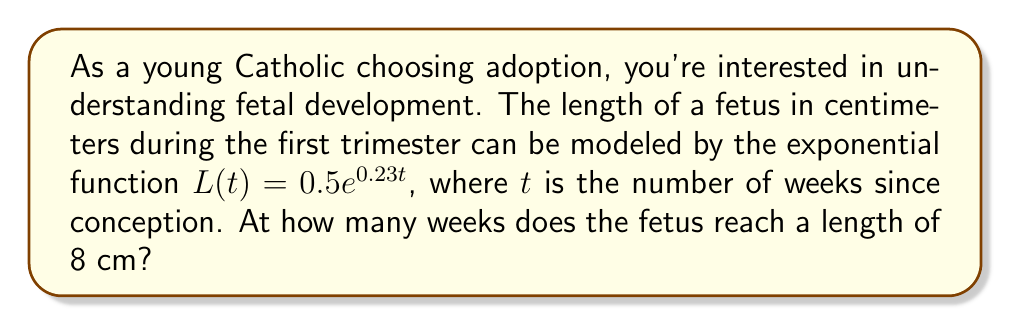Give your solution to this math problem. To solve this problem, we need to use the exponential equation and solve for $t$. Here's the step-by-step process:

1) We start with the equation: $L(t) = 0.5e^{0.23t}$

2) We want to find $t$ when $L(t) = 8$. So, we set up the equation:
   
   $8 = 0.5e^{0.23t}$

3) Divide both sides by 0.5:
   
   $16 = e^{0.23t}$

4) Take the natural logarithm of both sides:
   
   $\ln(16) = \ln(e^{0.23t})$

5) Using the property of logarithms $\ln(e^x) = x$, we get:
   
   $\ln(16) = 0.23t$

6) Solve for $t$:
   
   $t = \frac{\ln(16)}{0.23}$

7) Calculate the result:
   
   $t \approx 12.1$ weeks

Therefore, the fetus reaches a length of 8 cm at approximately 12.1 weeks after conception.
Answer: $t \approx 12.1$ weeks 